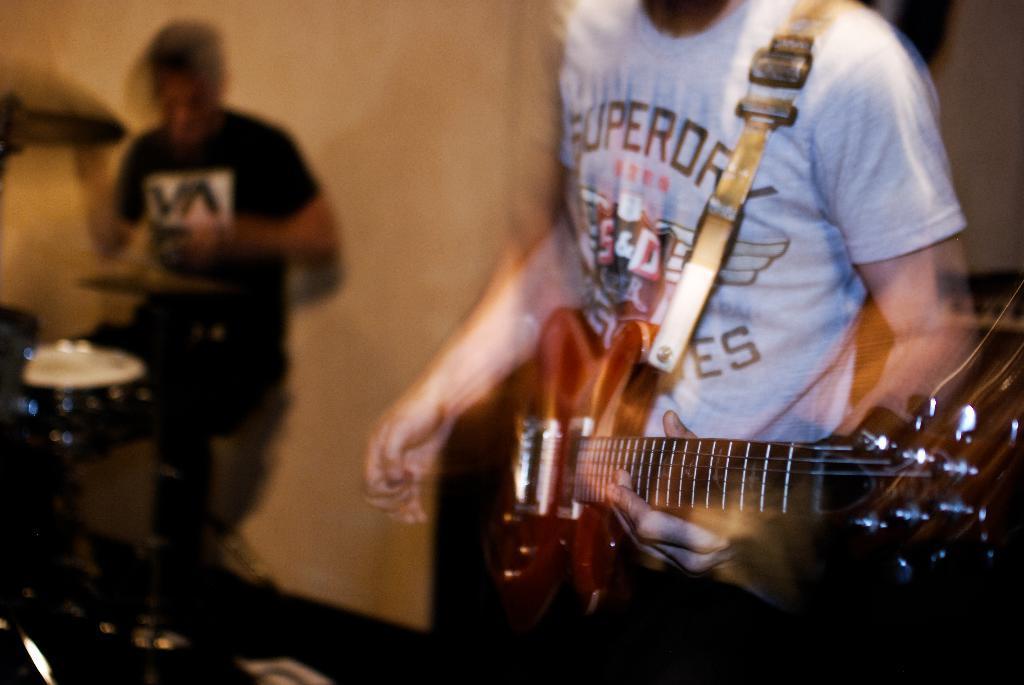In one or two sentences, can you explain what this image depicts? In this picture there is a person who is standing at the right side of the image, by holding the guitar in his hand and there is another person at the left side of the image he is playing the drums. 